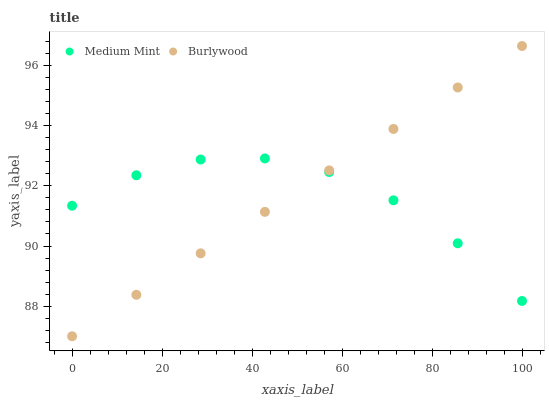Does Medium Mint have the minimum area under the curve?
Answer yes or no. Yes. Does Burlywood have the maximum area under the curve?
Answer yes or no. Yes. Does Burlywood have the minimum area under the curve?
Answer yes or no. No. Is Burlywood the smoothest?
Answer yes or no. Yes. Is Medium Mint the roughest?
Answer yes or no. Yes. Is Burlywood the roughest?
Answer yes or no. No. Does Burlywood have the lowest value?
Answer yes or no. Yes. Does Burlywood have the highest value?
Answer yes or no. Yes. Does Burlywood intersect Medium Mint?
Answer yes or no. Yes. Is Burlywood less than Medium Mint?
Answer yes or no. No. Is Burlywood greater than Medium Mint?
Answer yes or no. No. 